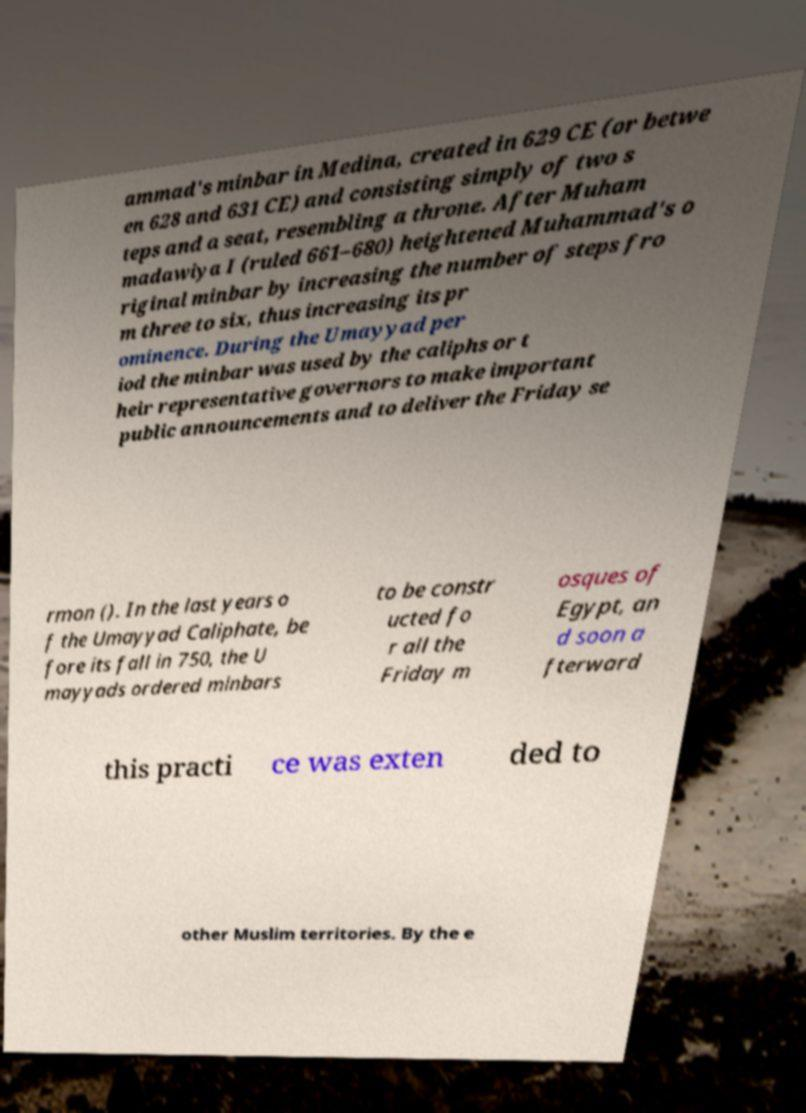Can you read and provide the text displayed in the image?This photo seems to have some interesting text. Can you extract and type it out for me? ammad's minbar in Medina, created in 629 CE (or betwe en 628 and 631 CE) and consisting simply of two s teps and a seat, resembling a throne. After Muham madawiya I (ruled 661–680) heightened Muhammad's o riginal minbar by increasing the number of steps fro m three to six, thus increasing its pr ominence. During the Umayyad per iod the minbar was used by the caliphs or t heir representative governors to make important public announcements and to deliver the Friday se rmon (). In the last years o f the Umayyad Caliphate, be fore its fall in 750, the U mayyads ordered minbars to be constr ucted fo r all the Friday m osques of Egypt, an d soon a fterward this practi ce was exten ded to other Muslim territories. By the e 